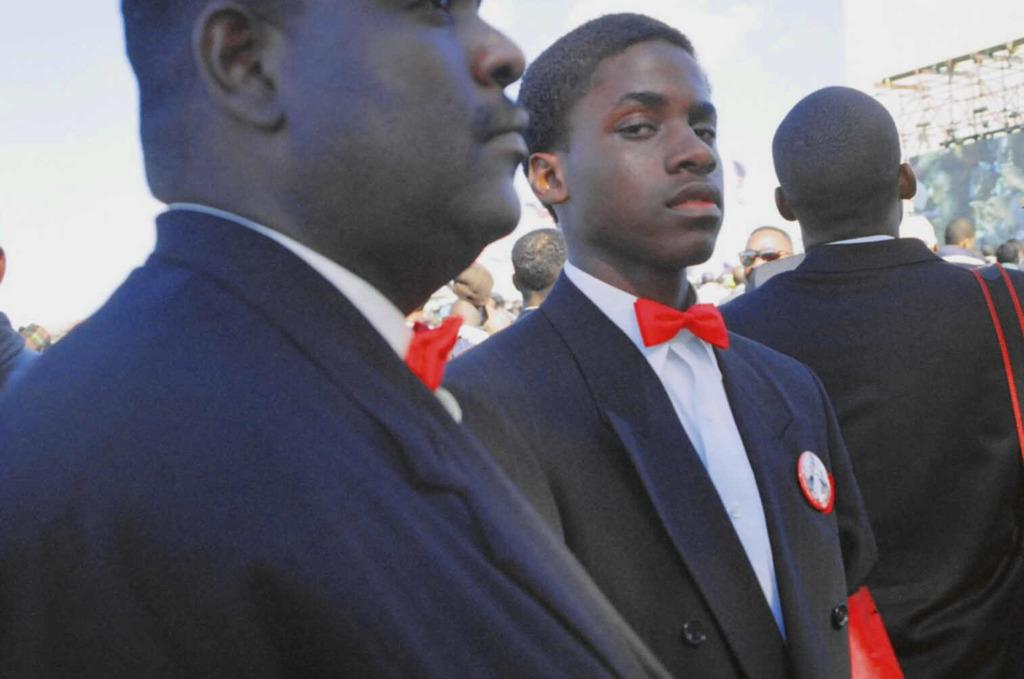Who or what can be seen in the image? There are people in the image. What are the people wearing? The people are wearing suits. What type of pleasure can be seen on the people's throats in the image? There is no indication of pleasure or any specific emotion on the people's throats in the image. 